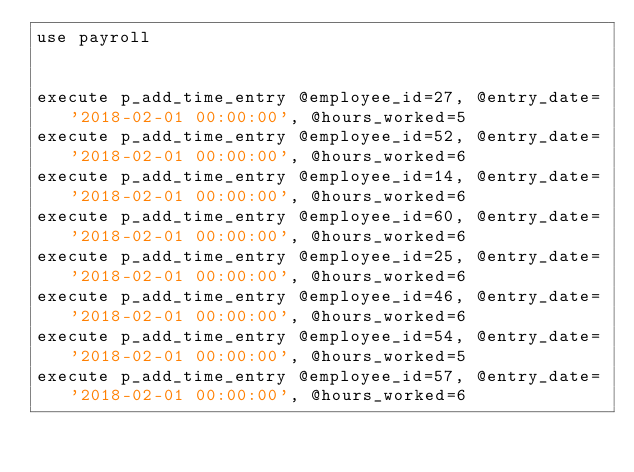Convert code to text. <code><loc_0><loc_0><loc_500><loc_500><_SQL_>use payroll


execute p_add_time_entry @employee_id=27, @entry_date='2018-02-01 00:00:00', @hours_worked=5
execute p_add_time_entry @employee_id=52, @entry_date='2018-02-01 00:00:00', @hours_worked=6
execute p_add_time_entry @employee_id=14, @entry_date='2018-02-01 00:00:00', @hours_worked=6
execute p_add_time_entry @employee_id=60, @entry_date='2018-02-01 00:00:00', @hours_worked=6
execute p_add_time_entry @employee_id=25, @entry_date='2018-02-01 00:00:00', @hours_worked=6
execute p_add_time_entry @employee_id=46, @entry_date='2018-02-01 00:00:00', @hours_worked=6
execute p_add_time_entry @employee_id=54, @entry_date='2018-02-01 00:00:00', @hours_worked=5
execute p_add_time_entry @employee_id=57, @entry_date='2018-02-01 00:00:00', @hours_worked=6

</code> 